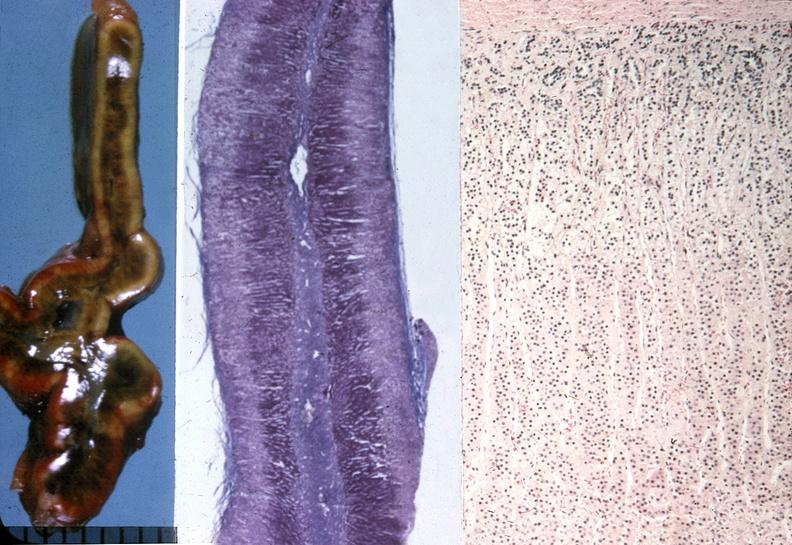what is present?
Answer the question using a single word or phrase. Endocrine 